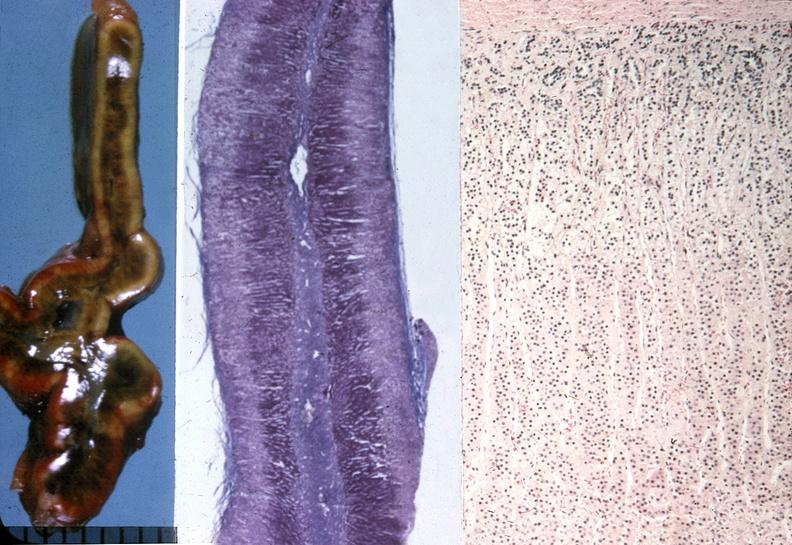what is present?
Answer the question using a single word or phrase. Endocrine 